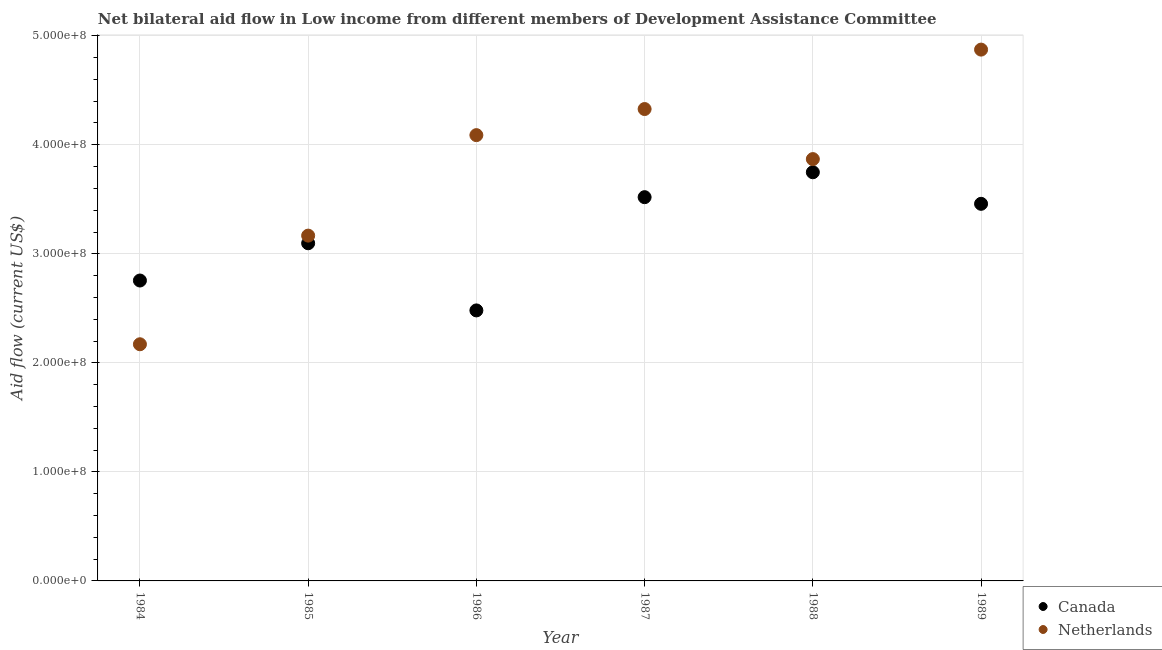How many different coloured dotlines are there?
Your answer should be very brief. 2. What is the amount of aid given by netherlands in 1988?
Your answer should be very brief. 3.87e+08. Across all years, what is the maximum amount of aid given by netherlands?
Your answer should be compact. 4.87e+08. Across all years, what is the minimum amount of aid given by canada?
Your answer should be very brief. 2.48e+08. What is the total amount of aid given by netherlands in the graph?
Give a very brief answer. 2.25e+09. What is the difference between the amount of aid given by canada in 1986 and that in 1988?
Your answer should be compact. -1.27e+08. What is the difference between the amount of aid given by netherlands in 1989 and the amount of aid given by canada in 1988?
Your answer should be very brief. 1.12e+08. What is the average amount of aid given by canada per year?
Provide a succinct answer. 3.18e+08. In the year 1984, what is the difference between the amount of aid given by netherlands and amount of aid given by canada?
Your answer should be compact. -5.85e+07. In how many years, is the amount of aid given by canada greater than 460000000 US$?
Provide a short and direct response. 0. What is the ratio of the amount of aid given by netherlands in 1986 to that in 1988?
Offer a terse response. 1.06. Is the amount of aid given by canada in 1987 less than that in 1988?
Provide a short and direct response. Yes. What is the difference between the highest and the second highest amount of aid given by canada?
Provide a succinct answer. 2.28e+07. What is the difference between the highest and the lowest amount of aid given by canada?
Your answer should be very brief. 1.27e+08. In how many years, is the amount of aid given by netherlands greater than the average amount of aid given by netherlands taken over all years?
Keep it short and to the point. 4. Does the amount of aid given by canada monotonically increase over the years?
Provide a short and direct response. No. How many dotlines are there?
Your answer should be very brief. 2. How many years are there in the graph?
Offer a very short reply. 6. What is the difference between two consecutive major ticks on the Y-axis?
Provide a succinct answer. 1.00e+08. Are the values on the major ticks of Y-axis written in scientific E-notation?
Make the answer very short. Yes. Does the graph contain any zero values?
Your answer should be very brief. No. Does the graph contain grids?
Keep it short and to the point. Yes. Where does the legend appear in the graph?
Offer a terse response. Bottom right. What is the title of the graph?
Provide a succinct answer. Net bilateral aid flow in Low income from different members of Development Assistance Committee. Does "Arms imports" appear as one of the legend labels in the graph?
Your answer should be very brief. No. What is the Aid flow (current US$) of Canada in 1984?
Provide a succinct answer. 2.76e+08. What is the Aid flow (current US$) in Netherlands in 1984?
Offer a terse response. 2.17e+08. What is the Aid flow (current US$) in Canada in 1985?
Your answer should be very brief. 3.10e+08. What is the Aid flow (current US$) in Netherlands in 1985?
Provide a succinct answer. 3.17e+08. What is the Aid flow (current US$) in Canada in 1986?
Offer a very short reply. 2.48e+08. What is the Aid flow (current US$) in Netherlands in 1986?
Your answer should be compact. 4.09e+08. What is the Aid flow (current US$) in Canada in 1987?
Your response must be concise. 3.52e+08. What is the Aid flow (current US$) of Netherlands in 1987?
Keep it short and to the point. 4.33e+08. What is the Aid flow (current US$) in Canada in 1988?
Give a very brief answer. 3.75e+08. What is the Aid flow (current US$) in Netherlands in 1988?
Give a very brief answer. 3.87e+08. What is the Aid flow (current US$) of Canada in 1989?
Offer a terse response. 3.46e+08. What is the Aid flow (current US$) of Netherlands in 1989?
Keep it short and to the point. 4.87e+08. Across all years, what is the maximum Aid flow (current US$) in Canada?
Ensure brevity in your answer.  3.75e+08. Across all years, what is the maximum Aid flow (current US$) of Netherlands?
Keep it short and to the point. 4.87e+08. Across all years, what is the minimum Aid flow (current US$) of Canada?
Your answer should be compact. 2.48e+08. Across all years, what is the minimum Aid flow (current US$) of Netherlands?
Give a very brief answer. 2.17e+08. What is the total Aid flow (current US$) of Canada in the graph?
Ensure brevity in your answer.  1.91e+09. What is the total Aid flow (current US$) of Netherlands in the graph?
Provide a short and direct response. 2.25e+09. What is the difference between the Aid flow (current US$) of Canada in 1984 and that in 1985?
Provide a short and direct response. -3.42e+07. What is the difference between the Aid flow (current US$) in Netherlands in 1984 and that in 1985?
Provide a short and direct response. -9.96e+07. What is the difference between the Aid flow (current US$) of Canada in 1984 and that in 1986?
Ensure brevity in your answer.  2.74e+07. What is the difference between the Aid flow (current US$) in Netherlands in 1984 and that in 1986?
Offer a very short reply. -1.92e+08. What is the difference between the Aid flow (current US$) in Canada in 1984 and that in 1987?
Provide a succinct answer. -7.64e+07. What is the difference between the Aid flow (current US$) in Netherlands in 1984 and that in 1987?
Keep it short and to the point. -2.16e+08. What is the difference between the Aid flow (current US$) of Canada in 1984 and that in 1988?
Provide a succinct answer. -9.93e+07. What is the difference between the Aid flow (current US$) of Netherlands in 1984 and that in 1988?
Your answer should be compact. -1.70e+08. What is the difference between the Aid flow (current US$) of Canada in 1984 and that in 1989?
Offer a very short reply. -7.03e+07. What is the difference between the Aid flow (current US$) in Netherlands in 1984 and that in 1989?
Provide a succinct answer. -2.70e+08. What is the difference between the Aid flow (current US$) of Canada in 1985 and that in 1986?
Give a very brief answer. 6.16e+07. What is the difference between the Aid flow (current US$) of Netherlands in 1985 and that in 1986?
Give a very brief answer. -9.22e+07. What is the difference between the Aid flow (current US$) in Canada in 1985 and that in 1987?
Give a very brief answer. -4.23e+07. What is the difference between the Aid flow (current US$) of Netherlands in 1985 and that in 1987?
Offer a terse response. -1.16e+08. What is the difference between the Aid flow (current US$) in Canada in 1985 and that in 1988?
Provide a succinct answer. -6.51e+07. What is the difference between the Aid flow (current US$) in Netherlands in 1985 and that in 1988?
Your answer should be very brief. -7.02e+07. What is the difference between the Aid flow (current US$) of Canada in 1985 and that in 1989?
Provide a succinct answer. -3.62e+07. What is the difference between the Aid flow (current US$) in Netherlands in 1985 and that in 1989?
Your response must be concise. -1.71e+08. What is the difference between the Aid flow (current US$) in Canada in 1986 and that in 1987?
Give a very brief answer. -1.04e+08. What is the difference between the Aid flow (current US$) of Netherlands in 1986 and that in 1987?
Keep it short and to the point. -2.39e+07. What is the difference between the Aid flow (current US$) in Canada in 1986 and that in 1988?
Your answer should be very brief. -1.27e+08. What is the difference between the Aid flow (current US$) in Netherlands in 1986 and that in 1988?
Your answer should be very brief. 2.20e+07. What is the difference between the Aid flow (current US$) of Canada in 1986 and that in 1989?
Keep it short and to the point. -9.78e+07. What is the difference between the Aid flow (current US$) of Netherlands in 1986 and that in 1989?
Your response must be concise. -7.84e+07. What is the difference between the Aid flow (current US$) of Canada in 1987 and that in 1988?
Give a very brief answer. -2.28e+07. What is the difference between the Aid flow (current US$) of Netherlands in 1987 and that in 1988?
Your answer should be compact. 4.59e+07. What is the difference between the Aid flow (current US$) of Canada in 1987 and that in 1989?
Your response must be concise. 6.10e+06. What is the difference between the Aid flow (current US$) in Netherlands in 1987 and that in 1989?
Offer a very short reply. -5.45e+07. What is the difference between the Aid flow (current US$) of Canada in 1988 and that in 1989?
Your answer should be compact. 2.90e+07. What is the difference between the Aid flow (current US$) of Netherlands in 1988 and that in 1989?
Offer a terse response. -1.00e+08. What is the difference between the Aid flow (current US$) of Canada in 1984 and the Aid flow (current US$) of Netherlands in 1985?
Make the answer very short. -4.12e+07. What is the difference between the Aid flow (current US$) in Canada in 1984 and the Aid flow (current US$) in Netherlands in 1986?
Your answer should be compact. -1.33e+08. What is the difference between the Aid flow (current US$) of Canada in 1984 and the Aid flow (current US$) of Netherlands in 1987?
Make the answer very short. -1.57e+08. What is the difference between the Aid flow (current US$) of Canada in 1984 and the Aid flow (current US$) of Netherlands in 1988?
Give a very brief answer. -1.11e+08. What is the difference between the Aid flow (current US$) of Canada in 1984 and the Aid flow (current US$) of Netherlands in 1989?
Provide a succinct answer. -2.12e+08. What is the difference between the Aid flow (current US$) in Canada in 1985 and the Aid flow (current US$) in Netherlands in 1986?
Offer a terse response. -9.92e+07. What is the difference between the Aid flow (current US$) in Canada in 1985 and the Aid flow (current US$) in Netherlands in 1987?
Make the answer very short. -1.23e+08. What is the difference between the Aid flow (current US$) in Canada in 1985 and the Aid flow (current US$) in Netherlands in 1988?
Your answer should be very brief. -7.72e+07. What is the difference between the Aid flow (current US$) in Canada in 1985 and the Aid flow (current US$) in Netherlands in 1989?
Give a very brief answer. -1.78e+08. What is the difference between the Aid flow (current US$) of Canada in 1986 and the Aid flow (current US$) of Netherlands in 1987?
Offer a terse response. -1.85e+08. What is the difference between the Aid flow (current US$) in Canada in 1986 and the Aid flow (current US$) in Netherlands in 1988?
Provide a succinct answer. -1.39e+08. What is the difference between the Aid flow (current US$) in Canada in 1986 and the Aid flow (current US$) in Netherlands in 1989?
Keep it short and to the point. -2.39e+08. What is the difference between the Aid flow (current US$) in Canada in 1987 and the Aid flow (current US$) in Netherlands in 1988?
Give a very brief answer. -3.49e+07. What is the difference between the Aid flow (current US$) in Canada in 1987 and the Aid flow (current US$) in Netherlands in 1989?
Offer a very short reply. -1.35e+08. What is the difference between the Aid flow (current US$) in Canada in 1988 and the Aid flow (current US$) in Netherlands in 1989?
Ensure brevity in your answer.  -1.12e+08. What is the average Aid flow (current US$) in Canada per year?
Offer a terse response. 3.18e+08. What is the average Aid flow (current US$) of Netherlands per year?
Provide a succinct answer. 3.75e+08. In the year 1984, what is the difference between the Aid flow (current US$) in Canada and Aid flow (current US$) in Netherlands?
Provide a succinct answer. 5.85e+07. In the year 1985, what is the difference between the Aid flow (current US$) in Canada and Aid flow (current US$) in Netherlands?
Provide a short and direct response. -7.01e+06. In the year 1986, what is the difference between the Aid flow (current US$) of Canada and Aid flow (current US$) of Netherlands?
Offer a very short reply. -1.61e+08. In the year 1987, what is the difference between the Aid flow (current US$) of Canada and Aid flow (current US$) of Netherlands?
Offer a terse response. -8.08e+07. In the year 1988, what is the difference between the Aid flow (current US$) of Canada and Aid flow (current US$) of Netherlands?
Your answer should be compact. -1.21e+07. In the year 1989, what is the difference between the Aid flow (current US$) in Canada and Aid flow (current US$) in Netherlands?
Make the answer very short. -1.41e+08. What is the ratio of the Aid flow (current US$) of Canada in 1984 to that in 1985?
Give a very brief answer. 0.89. What is the ratio of the Aid flow (current US$) of Netherlands in 1984 to that in 1985?
Your response must be concise. 0.69. What is the ratio of the Aid flow (current US$) of Canada in 1984 to that in 1986?
Provide a succinct answer. 1.11. What is the ratio of the Aid flow (current US$) in Netherlands in 1984 to that in 1986?
Offer a very short reply. 0.53. What is the ratio of the Aid flow (current US$) of Canada in 1984 to that in 1987?
Ensure brevity in your answer.  0.78. What is the ratio of the Aid flow (current US$) of Netherlands in 1984 to that in 1987?
Keep it short and to the point. 0.5. What is the ratio of the Aid flow (current US$) of Canada in 1984 to that in 1988?
Your response must be concise. 0.74. What is the ratio of the Aid flow (current US$) of Netherlands in 1984 to that in 1988?
Your response must be concise. 0.56. What is the ratio of the Aid flow (current US$) of Canada in 1984 to that in 1989?
Your answer should be compact. 0.8. What is the ratio of the Aid flow (current US$) of Netherlands in 1984 to that in 1989?
Your answer should be compact. 0.45. What is the ratio of the Aid flow (current US$) of Canada in 1985 to that in 1986?
Give a very brief answer. 1.25. What is the ratio of the Aid flow (current US$) of Netherlands in 1985 to that in 1986?
Give a very brief answer. 0.77. What is the ratio of the Aid flow (current US$) in Canada in 1985 to that in 1987?
Provide a succinct answer. 0.88. What is the ratio of the Aid flow (current US$) in Netherlands in 1985 to that in 1987?
Make the answer very short. 0.73. What is the ratio of the Aid flow (current US$) in Canada in 1985 to that in 1988?
Make the answer very short. 0.83. What is the ratio of the Aid flow (current US$) of Netherlands in 1985 to that in 1988?
Provide a short and direct response. 0.82. What is the ratio of the Aid flow (current US$) in Canada in 1985 to that in 1989?
Offer a terse response. 0.9. What is the ratio of the Aid flow (current US$) in Netherlands in 1985 to that in 1989?
Your response must be concise. 0.65. What is the ratio of the Aid flow (current US$) of Canada in 1986 to that in 1987?
Offer a terse response. 0.7. What is the ratio of the Aid flow (current US$) of Netherlands in 1986 to that in 1987?
Keep it short and to the point. 0.94. What is the ratio of the Aid flow (current US$) of Canada in 1986 to that in 1988?
Keep it short and to the point. 0.66. What is the ratio of the Aid flow (current US$) of Netherlands in 1986 to that in 1988?
Keep it short and to the point. 1.06. What is the ratio of the Aid flow (current US$) of Canada in 1986 to that in 1989?
Keep it short and to the point. 0.72. What is the ratio of the Aid flow (current US$) of Netherlands in 1986 to that in 1989?
Offer a terse response. 0.84. What is the ratio of the Aid flow (current US$) in Canada in 1987 to that in 1988?
Give a very brief answer. 0.94. What is the ratio of the Aid flow (current US$) in Netherlands in 1987 to that in 1988?
Keep it short and to the point. 1.12. What is the ratio of the Aid flow (current US$) of Canada in 1987 to that in 1989?
Your response must be concise. 1.02. What is the ratio of the Aid flow (current US$) of Netherlands in 1987 to that in 1989?
Provide a succinct answer. 0.89. What is the ratio of the Aid flow (current US$) in Canada in 1988 to that in 1989?
Give a very brief answer. 1.08. What is the ratio of the Aid flow (current US$) of Netherlands in 1988 to that in 1989?
Your response must be concise. 0.79. What is the difference between the highest and the second highest Aid flow (current US$) in Canada?
Give a very brief answer. 2.28e+07. What is the difference between the highest and the second highest Aid flow (current US$) in Netherlands?
Ensure brevity in your answer.  5.45e+07. What is the difference between the highest and the lowest Aid flow (current US$) in Canada?
Offer a terse response. 1.27e+08. What is the difference between the highest and the lowest Aid flow (current US$) in Netherlands?
Provide a succinct answer. 2.70e+08. 